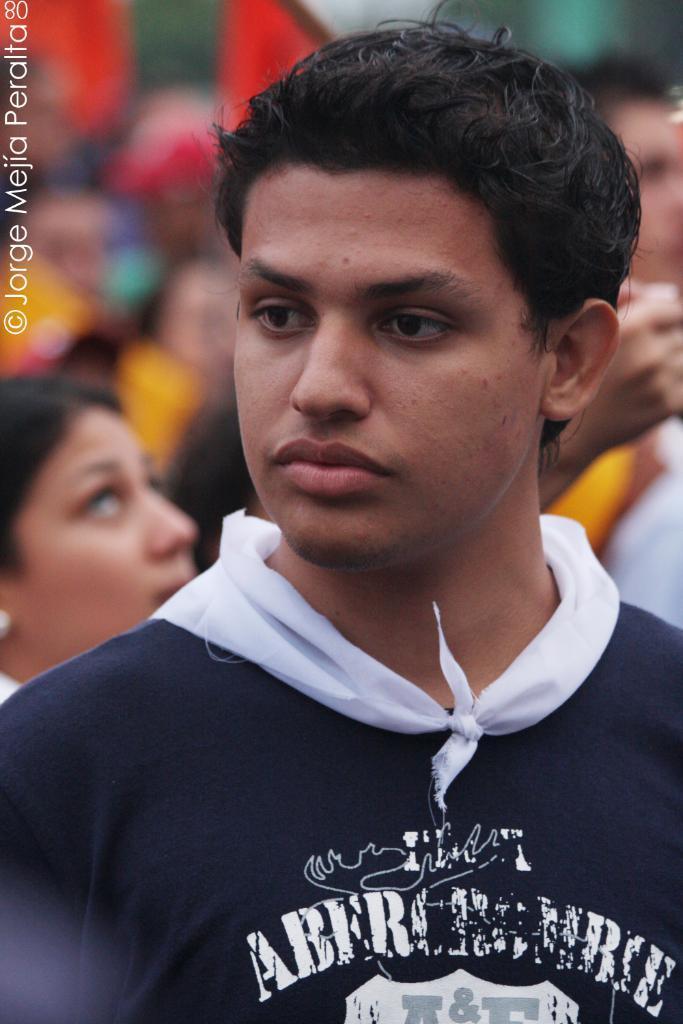How would you summarize this image in a sentence or two? Front this person is looking left side of the image. Left side of the image there is a watermark. Background it is blurry and we can see people. 